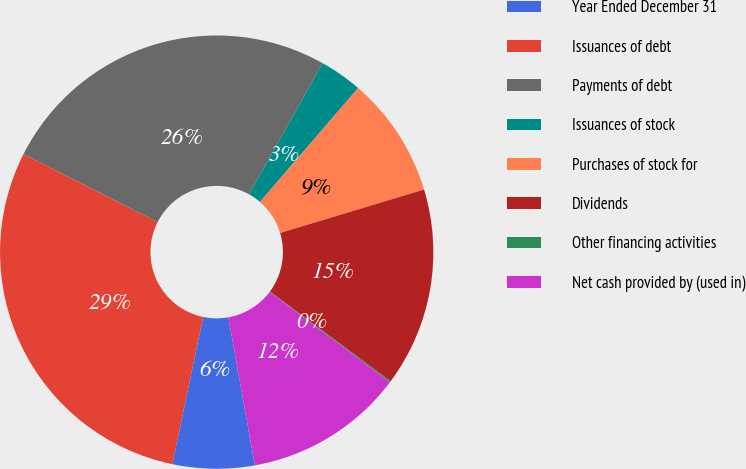<chart> <loc_0><loc_0><loc_500><loc_500><pie_chart><fcel>Year Ended December 31<fcel>Issuances of debt<fcel>Payments of debt<fcel>Issuances of stock<fcel>Purchases of stock for<fcel>Dividends<fcel>Other financing activities<fcel>Net cash provided by (used in)<nl><fcel>6.1%<fcel>29.2%<fcel>25.66%<fcel>3.19%<fcel>9.01%<fcel>14.83%<fcel>0.1%<fcel>11.92%<nl></chart> 